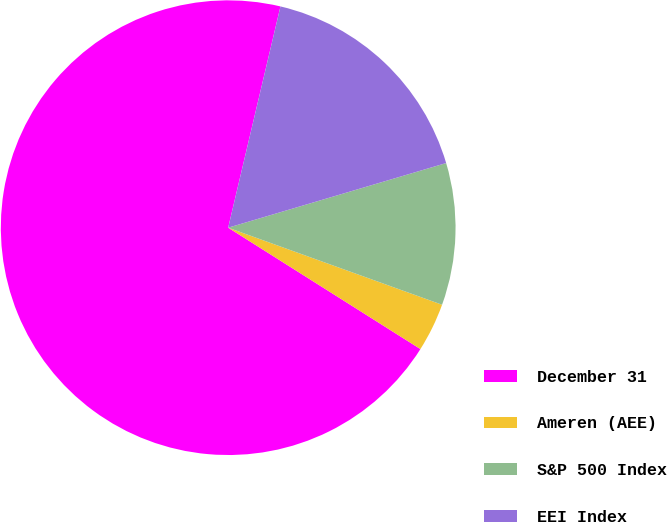Convert chart. <chart><loc_0><loc_0><loc_500><loc_500><pie_chart><fcel>December 31<fcel>Ameren (AEE)<fcel>S&P 500 Index<fcel>EEI Index<nl><fcel>69.73%<fcel>3.46%<fcel>10.09%<fcel>16.72%<nl></chart> 